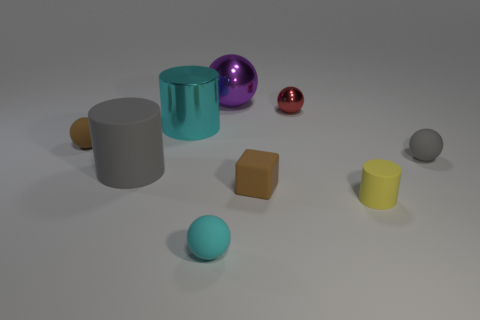Add 5 rubber cylinders. How many rubber cylinders exist? 7 Add 1 metal objects. How many objects exist? 10 Subtract all gray spheres. How many spheres are left? 4 Subtract all brown matte balls. How many balls are left? 4 Subtract 0 red blocks. How many objects are left? 9 Subtract all blocks. How many objects are left? 8 Subtract 1 cubes. How many cubes are left? 0 Subtract all yellow blocks. Subtract all brown balls. How many blocks are left? 1 Subtract all green cubes. How many purple balls are left? 1 Subtract all brown rubber blocks. Subtract all gray matte balls. How many objects are left? 7 